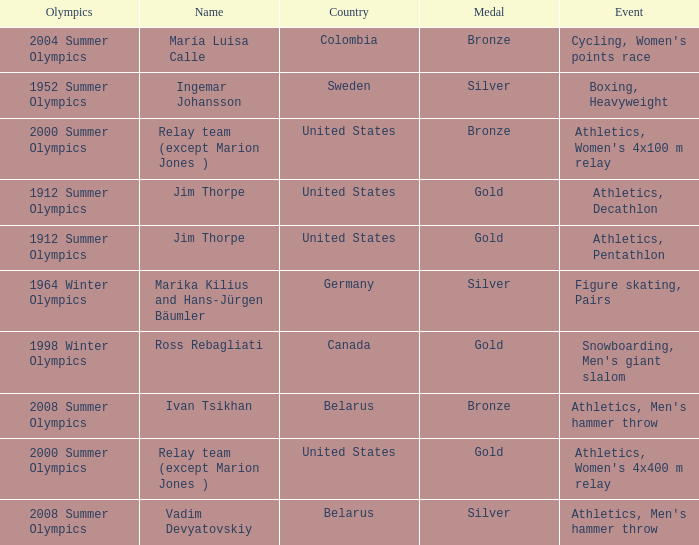Which event is in the 1952 summer olympics? Boxing, Heavyweight. 